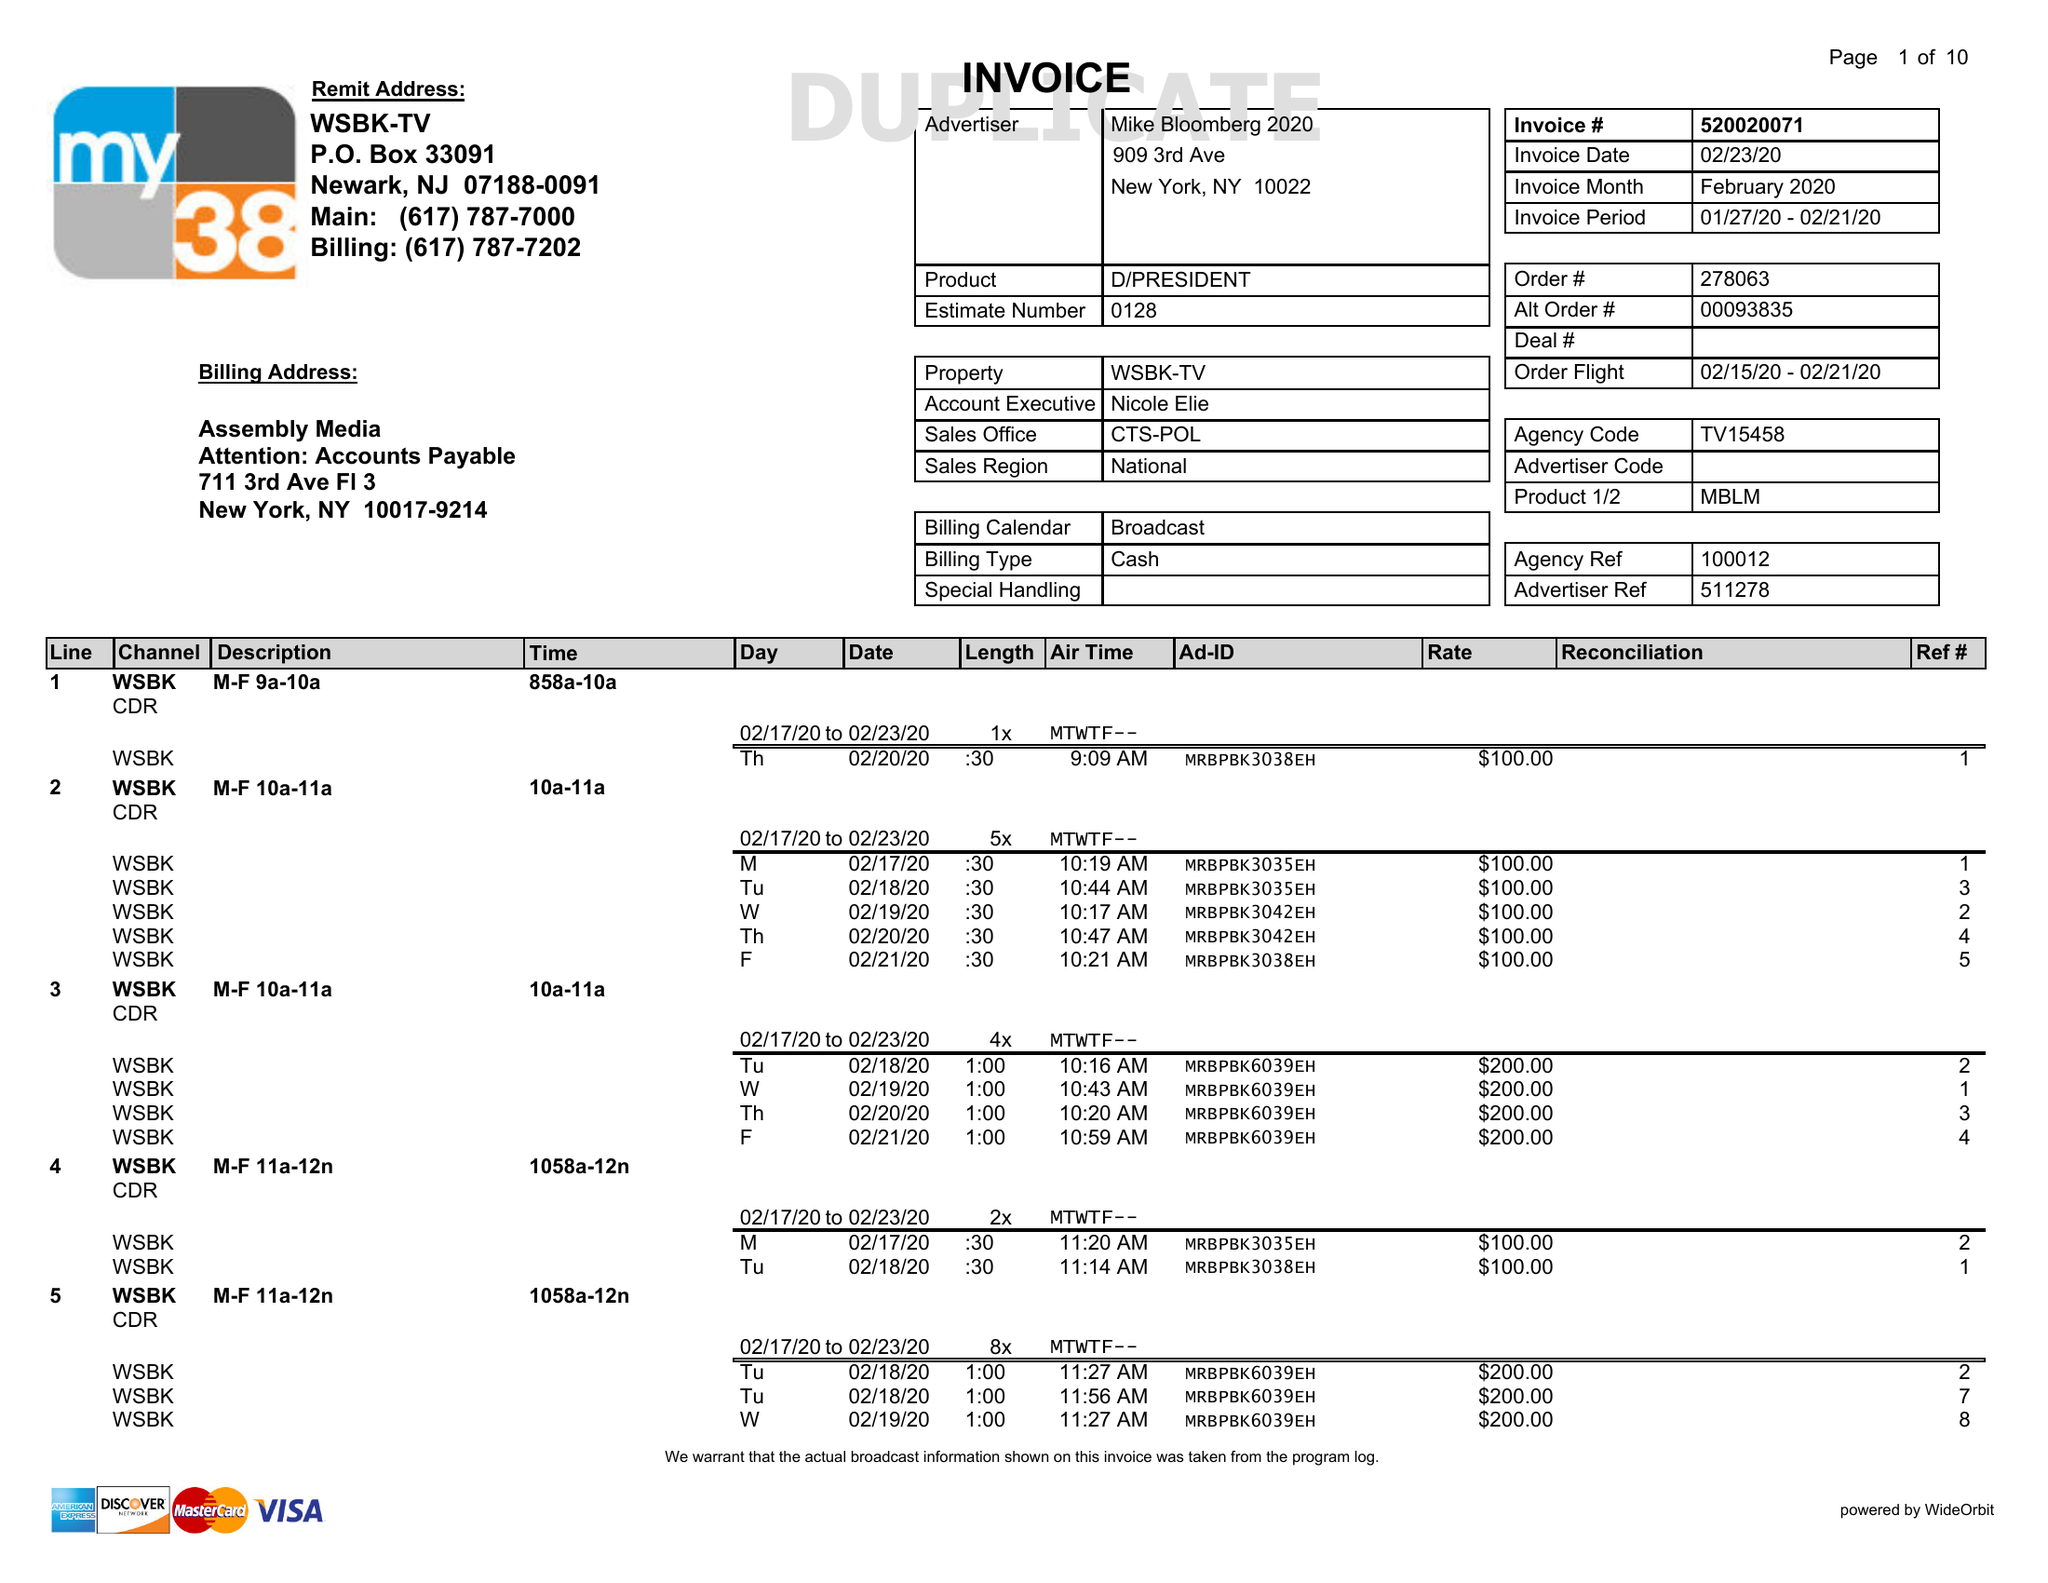What is the value for the flight_to?
Answer the question using a single word or phrase. 02/21/20 